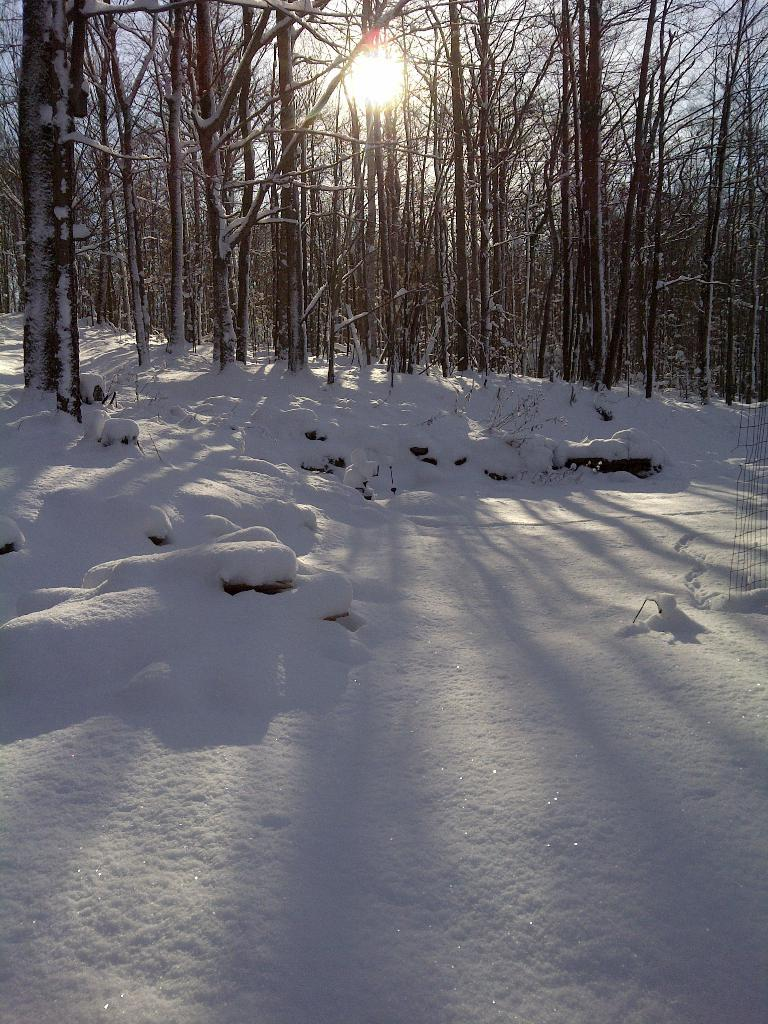What type of vegetation can be seen in the image? There is a group of trees in the image. What celestial body is visible in the image? The sun is visible in the image. What part of the natural environment is visible in the image? The sky is visible in the image. What is the ground covered with in the image? The ground is covered with snow. What type of fish can be seen swimming in the snow in the image? There are no fish present in the image, and fish cannot swim in snow. 